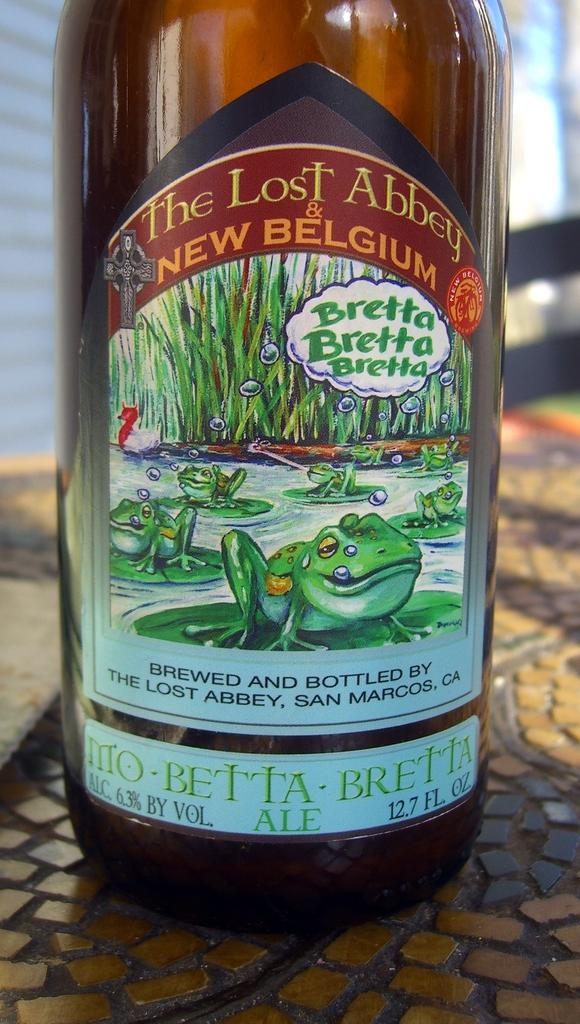<image>
Create a compact narrative representing the image presented. A bottle of The Lost Abbey New Belgium the label contains various frogs. 